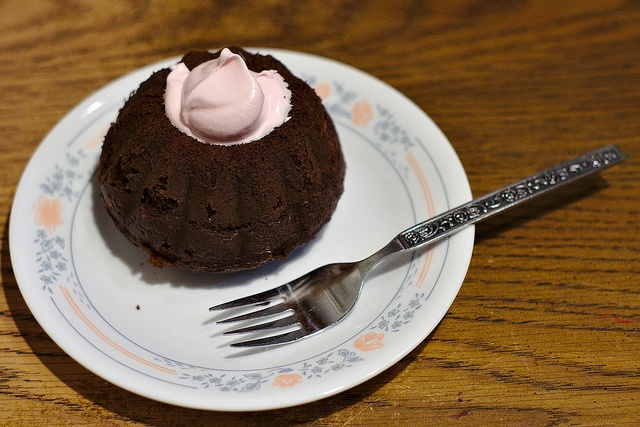Describe the objects in this image and their specific colors. I can see dining table in maroon, olive, and black tones, cake in brown, black, maroon, lightgray, and pink tones, and fork in brown, black, gray, and darkgray tones in this image. 